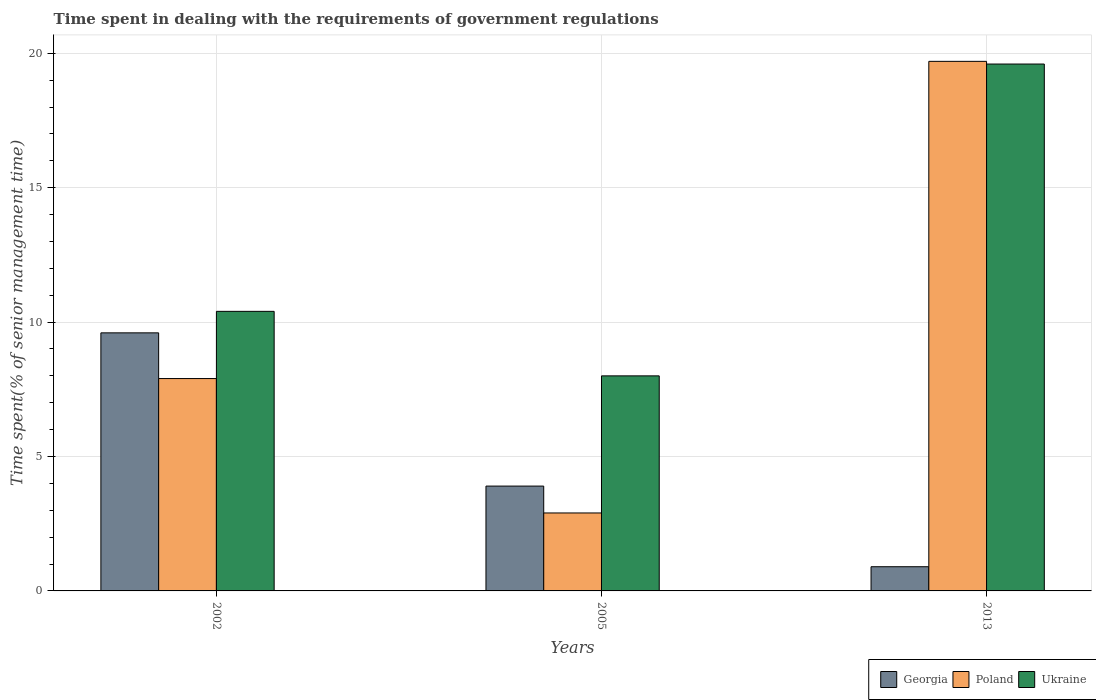How many different coloured bars are there?
Offer a terse response. 3. How many groups of bars are there?
Keep it short and to the point. 3. Are the number of bars on each tick of the X-axis equal?
Your answer should be very brief. Yes. How many bars are there on the 2nd tick from the left?
Provide a short and direct response. 3. Across all years, what is the minimum time spent while dealing with the requirements of government regulations in Poland?
Make the answer very short. 2.9. In which year was the time spent while dealing with the requirements of government regulations in Georgia maximum?
Provide a succinct answer. 2002. In which year was the time spent while dealing with the requirements of government regulations in Poland minimum?
Offer a very short reply. 2005. What is the difference between the time spent while dealing with the requirements of government regulations in Poland in 2002 and that in 2013?
Keep it short and to the point. -11.8. What is the difference between the time spent while dealing with the requirements of government regulations in Poland in 2005 and the time spent while dealing with the requirements of government regulations in Ukraine in 2013?
Offer a very short reply. -16.7. What is the average time spent while dealing with the requirements of government regulations in Ukraine per year?
Provide a succinct answer. 12.67. In the year 2005, what is the difference between the time spent while dealing with the requirements of government regulations in Ukraine and time spent while dealing with the requirements of government regulations in Georgia?
Your answer should be compact. 4.1. What is the ratio of the time spent while dealing with the requirements of government regulations in Georgia in 2002 to that in 2005?
Ensure brevity in your answer.  2.46. Is the time spent while dealing with the requirements of government regulations in Georgia in 2005 less than that in 2013?
Provide a short and direct response. No. What is the difference between the highest and the second highest time spent while dealing with the requirements of government regulations in Ukraine?
Offer a very short reply. 9.2. Is the sum of the time spent while dealing with the requirements of government regulations in Poland in 2002 and 2005 greater than the maximum time spent while dealing with the requirements of government regulations in Georgia across all years?
Keep it short and to the point. Yes. What does the 1st bar from the left in 2002 represents?
Keep it short and to the point. Georgia. Are all the bars in the graph horizontal?
Give a very brief answer. No. How many years are there in the graph?
Offer a very short reply. 3. Does the graph contain any zero values?
Your answer should be very brief. No. Does the graph contain grids?
Provide a succinct answer. Yes. How many legend labels are there?
Offer a very short reply. 3. How are the legend labels stacked?
Your answer should be compact. Horizontal. What is the title of the graph?
Give a very brief answer. Time spent in dealing with the requirements of government regulations. Does "Zimbabwe" appear as one of the legend labels in the graph?
Provide a short and direct response. No. What is the label or title of the X-axis?
Provide a short and direct response. Years. What is the label or title of the Y-axis?
Offer a terse response. Time spent(% of senior management time). What is the Time spent(% of senior management time) of Ukraine in 2002?
Your response must be concise. 10.4. What is the Time spent(% of senior management time) in Georgia in 2005?
Make the answer very short. 3.9. What is the Time spent(% of senior management time) in Ukraine in 2013?
Make the answer very short. 19.6. Across all years, what is the maximum Time spent(% of senior management time) in Georgia?
Make the answer very short. 9.6. Across all years, what is the maximum Time spent(% of senior management time) in Poland?
Your answer should be very brief. 19.7. Across all years, what is the maximum Time spent(% of senior management time) in Ukraine?
Your answer should be very brief. 19.6. Across all years, what is the minimum Time spent(% of senior management time) of Poland?
Ensure brevity in your answer.  2.9. What is the total Time spent(% of senior management time) in Poland in the graph?
Offer a terse response. 30.5. What is the difference between the Time spent(% of senior management time) in Georgia in 2002 and that in 2005?
Give a very brief answer. 5.7. What is the difference between the Time spent(% of senior management time) of Poland in 2002 and that in 2005?
Your answer should be very brief. 5. What is the difference between the Time spent(% of senior management time) of Poland in 2002 and that in 2013?
Your answer should be very brief. -11.8. What is the difference between the Time spent(% of senior management time) in Ukraine in 2002 and that in 2013?
Your answer should be compact. -9.2. What is the difference between the Time spent(% of senior management time) in Georgia in 2005 and that in 2013?
Your answer should be very brief. 3. What is the difference between the Time spent(% of senior management time) in Poland in 2005 and that in 2013?
Your answer should be compact. -16.8. What is the difference between the Time spent(% of senior management time) in Ukraine in 2005 and that in 2013?
Keep it short and to the point. -11.6. What is the difference between the Time spent(% of senior management time) of Georgia in 2002 and the Time spent(% of senior management time) of Poland in 2005?
Ensure brevity in your answer.  6.7. What is the difference between the Time spent(% of senior management time) in Georgia in 2002 and the Time spent(% of senior management time) in Poland in 2013?
Your response must be concise. -10.1. What is the difference between the Time spent(% of senior management time) in Georgia in 2002 and the Time spent(% of senior management time) in Ukraine in 2013?
Make the answer very short. -10. What is the difference between the Time spent(% of senior management time) of Georgia in 2005 and the Time spent(% of senior management time) of Poland in 2013?
Provide a short and direct response. -15.8. What is the difference between the Time spent(% of senior management time) of Georgia in 2005 and the Time spent(% of senior management time) of Ukraine in 2013?
Offer a very short reply. -15.7. What is the difference between the Time spent(% of senior management time) of Poland in 2005 and the Time spent(% of senior management time) of Ukraine in 2013?
Provide a short and direct response. -16.7. What is the average Time spent(% of senior management time) in Poland per year?
Your answer should be compact. 10.17. What is the average Time spent(% of senior management time) in Ukraine per year?
Give a very brief answer. 12.67. In the year 2002, what is the difference between the Time spent(% of senior management time) in Poland and Time spent(% of senior management time) in Ukraine?
Make the answer very short. -2.5. In the year 2005, what is the difference between the Time spent(% of senior management time) in Georgia and Time spent(% of senior management time) in Ukraine?
Provide a succinct answer. -4.1. In the year 2013, what is the difference between the Time spent(% of senior management time) of Georgia and Time spent(% of senior management time) of Poland?
Provide a short and direct response. -18.8. In the year 2013, what is the difference between the Time spent(% of senior management time) in Georgia and Time spent(% of senior management time) in Ukraine?
Offer a terse response. -18.7. In the year 2013, what is the difference between the Time spent(% of senior management time) in Poland and Time spent(% of senior management time) in Ukraine?
Your response must be concise. 0.1. What is the ratio of the Time spent(% of senior management time) in Georgia in 2002 to that in 2005?
Offer a very short reply. 2.46. What is the ratio of the Time spent(% of senior management time) of Poland in 2002 to that in 2005?
Your response must be concise. 2.72. What is the ratio of the Time spent(% of senior management time) of Georgia in 2002 to that in 2013?
Offer a terse response. 10.67. What is the ratio of the Time spent(% of senior management time) of Poland in 2002 to that in 2013?
Make the answer very short. 0.4. What is the ratio of the Time spent(% of senior management time) in Ukraine in 2002 to that in 2013?
Your response must be concise. 0.53. What is the ratio of the Time spent(% of senior management time) of Georgia in 2005 to that in 2013?
Provide a succinct answer. 4.33. What is the ratio of the Time spent(% of senior management time) of Poland in 2005 to that in 2013?
Offer a terse response. 0.15. What is the ratio of the Time spent(% of senior management time) in Ukraine in 2005 to that in 2013?
Provide a short and direct response. 0.41. What is the difference between the highest and the second highest Time spent(% of senior management time) of Georgia?
Offer a very short reply. 5.7. What is the difference between the highest and the second highest Time spent(% of senior management time) of Ukraine?
Your answer should be compact. 9.2. What is the difference between the highest and the lowest Time spent(% of senior management time) of Poland?
Provide a succinct answer. 16.8. What is the difference between the highest and the lowest Time spent(% of senior management time) of Ukraine?
Give a very brief answer. 11.6. 